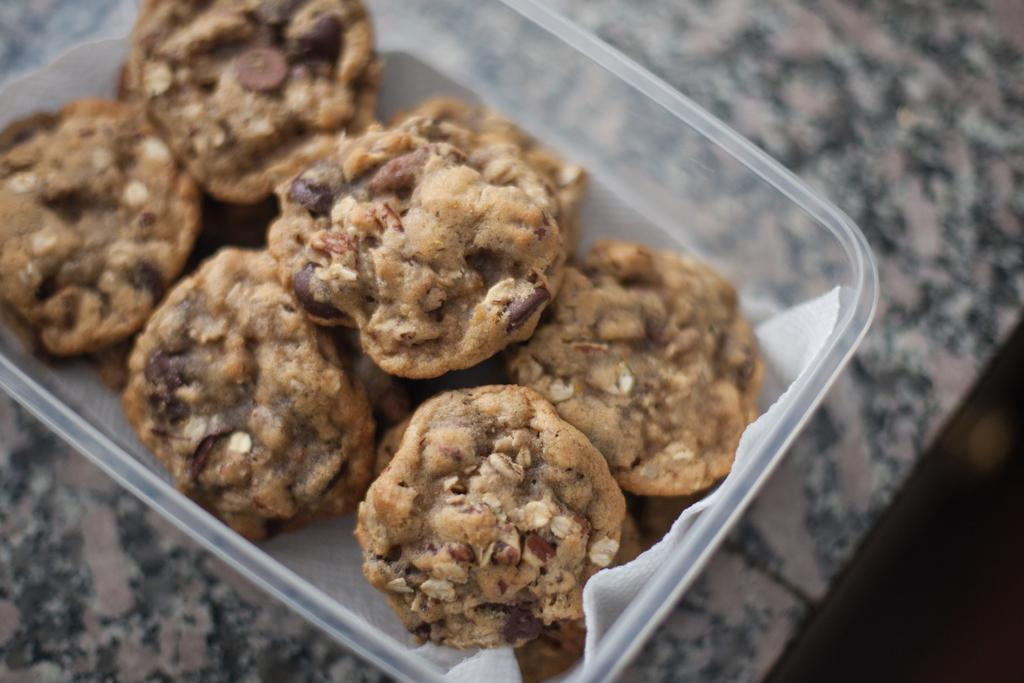What is the main subject of the image? The main subject of the image is food. How is the food contained in the image? The food is in a box. What is the color of the food in the image? The food is brown in color. Where is the box with the food located? The box is on a surface. What type of lettuce is being used as a credit card in the image? There is no lettuce or credit card present in the image; it only features food in a brown color contained in a box on a surface. 